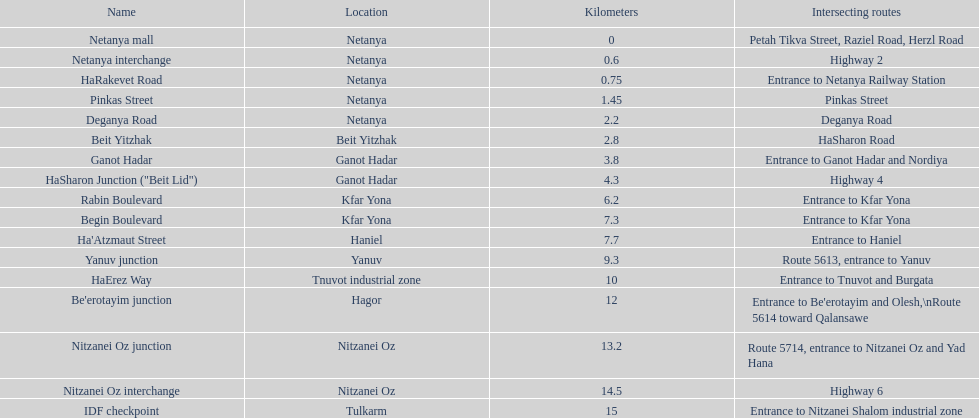After you complete deganya road, what portion comes next? Beit Yitzhak. 